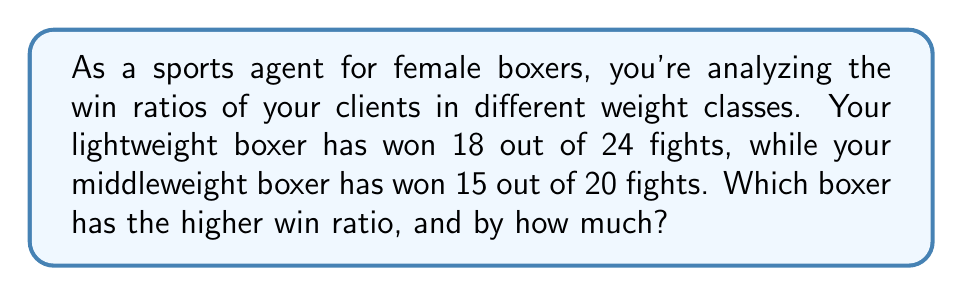Solve this math problem. Let's approach this step-by-step:

1) First, we need to calculate the win ratios for each boxer:

   Lightweight boxer: $\frac{18}{24}$
   Middleweight boxer: $\frac{15}{20}$

2) To compare these fractions, we need to find a common denominator. The least common multiple of 24 and 20 is 120.

3) Let's convert each fraction to an equivalent fraction with a denominator of 120:

   Lightweight: $\frac{18}{24} = \frac{18 \times 5}{24 \times 5} = \frac{90}{120}$
   Middleweight: $\frac{15}{20} = \frac{15 \times 6}{20 \times 6} = \frac{90}{120}$

4) Now we can see that both boxers have the same win ratio: $\frac{90}{120}$ or $\frac{3}{4}$

5) To express this as a decimal, we can divide 3 by 4:

   $\frac{3}{4} = 0.75$ or 75%

6) Since both boxers have the same win ratio, the difference between their ratios is 0.
Answer: Both boxers have equal win ratios of $\frac{3}{4}$ (0.75 or 75%). The difference is 0. 